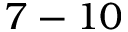Convert formula to latex. <formula><loc_0><loc_0><loc_500><loc_500>7 - 1 0</formula> 